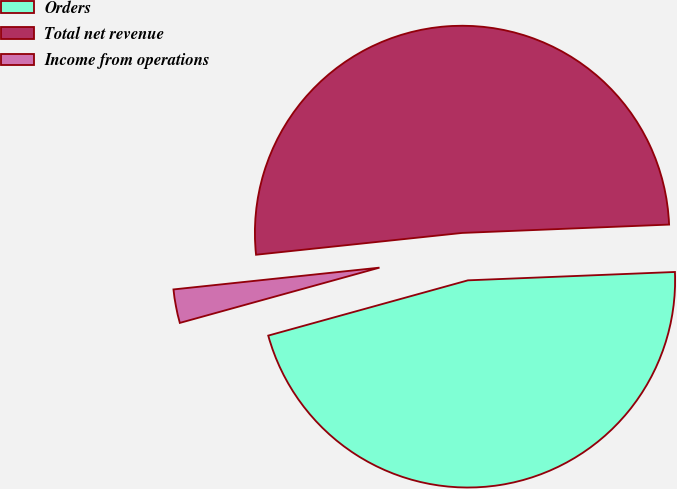Convert chart to OTSL. <chart><loc_0><loc_0><loc_500><loc_500><pie_chart><fcel>Orders<fcel>Total net revenue<fcel>Income from operations<nl><fcel>46.34%<fcel>51.03%<fcel>2.62%<nl></chart> 